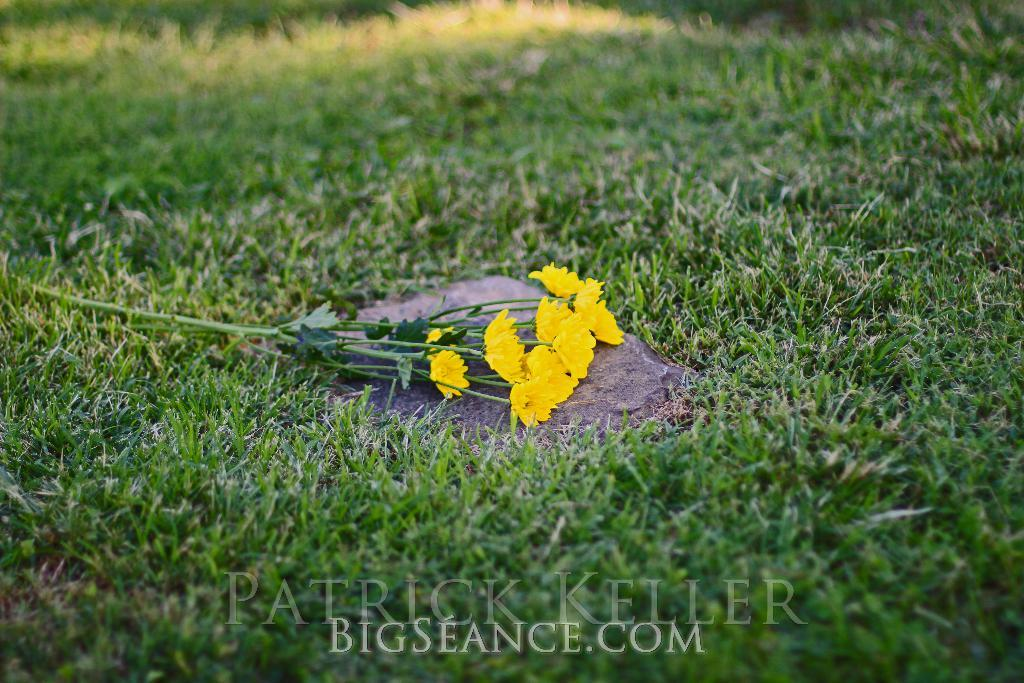What type of vegetation covers the land in the image? The land in the image is covered with grass. What geological feature can be seen in the image? There is a rock in the image. Are there any flowers present in the image? Yes, a bunch of yellow flowers is placed on the rock. What type of soup is being served during recess in the image? There is no soup or recess present in the image; it features a rock with yellow flowers on it. How many children are playing in the image? There are no children present in the image. 